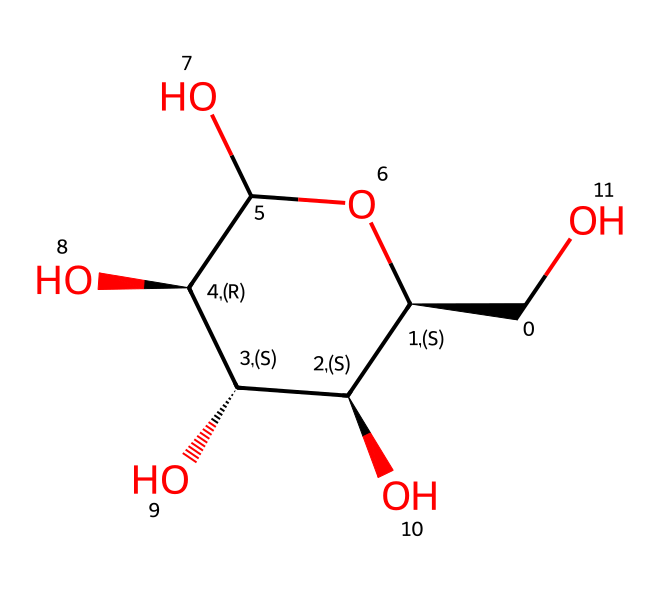What is the molecular formula of D-glucose? To determine the molecular formula, count all the carbon (C), hydrogen (H), and oxygen (O) atoms in the structure. In the given SMILES, there are 6 carbons, 12 hydrogens, and 6 oxygens.
Answer: C6H12O6 How many chiral centers are present in D-glucose? By examining the structure, we look for carbons that are bonded to four different groups. In D-glucose, there are four such carbons (C2, C3, C4, and C5), which means it has four chiral centers.
Answer: 4 What type of carbohydrate is D-glucose classified as? D-glucose is classified based on its structure and function; being a simple sugar with a monomeric structure, it is classified specifically as a monosaccharide.
Answer: monosaccharide Which functional group is present in D-glucose? The primary functional group in D-glucose is the hydroxyl (-OH) group, which is characteristic of alcohols. This is evident as there are multiple -OH groups in the structure.
Answer: hydroxyl How does the presence of chiral centers in D-glucose affect its optical activity? The presence of chiral centers means that D-glucose can rotate plane-polarized light in a specific direction due to its asymmetric structure. This is a characteristic of chiral compounds and is related to their optical isomers.
Answer: it is optically active Name a common reaction D-glucose undergoes due to its aldehyde group. D-glucose, being an aldose, can participate in oxidation reactions where the aldehyde group can be oxidized to a carboxylic acid, as seen in reactions with agents like Benedict's reagent.
Answer: oxidation 